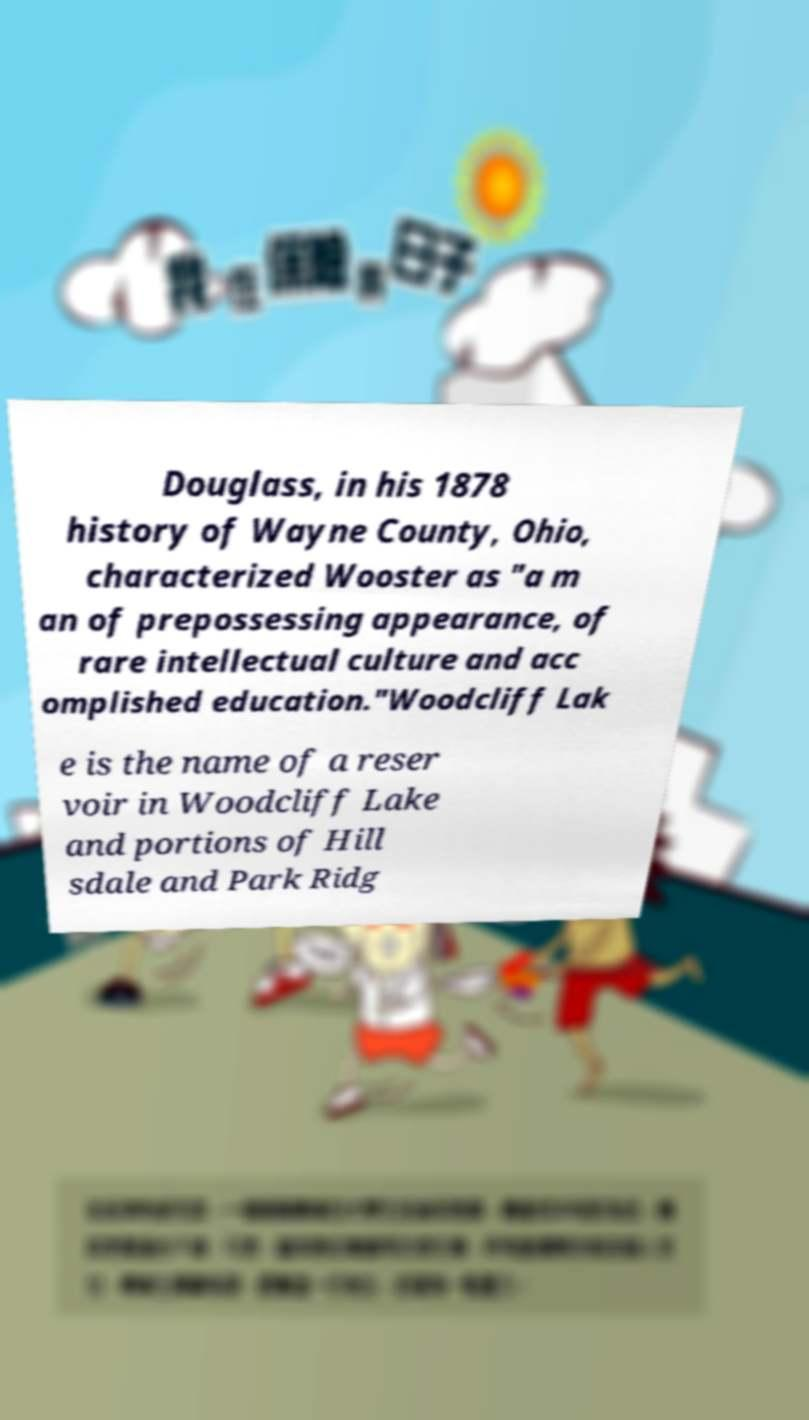I need the written content from this picture converted into text. Can you do that? Douglass, in his 1878 history of Wayne County, Ohio, characterized Wooster as "a m an of prepossessing appearance, of rare intellectual culture and acc omplished education."Woodcliff Lak e is the name of a reser voir in Woodcliff Lake and portions of Hill sdale and Park Ridg 